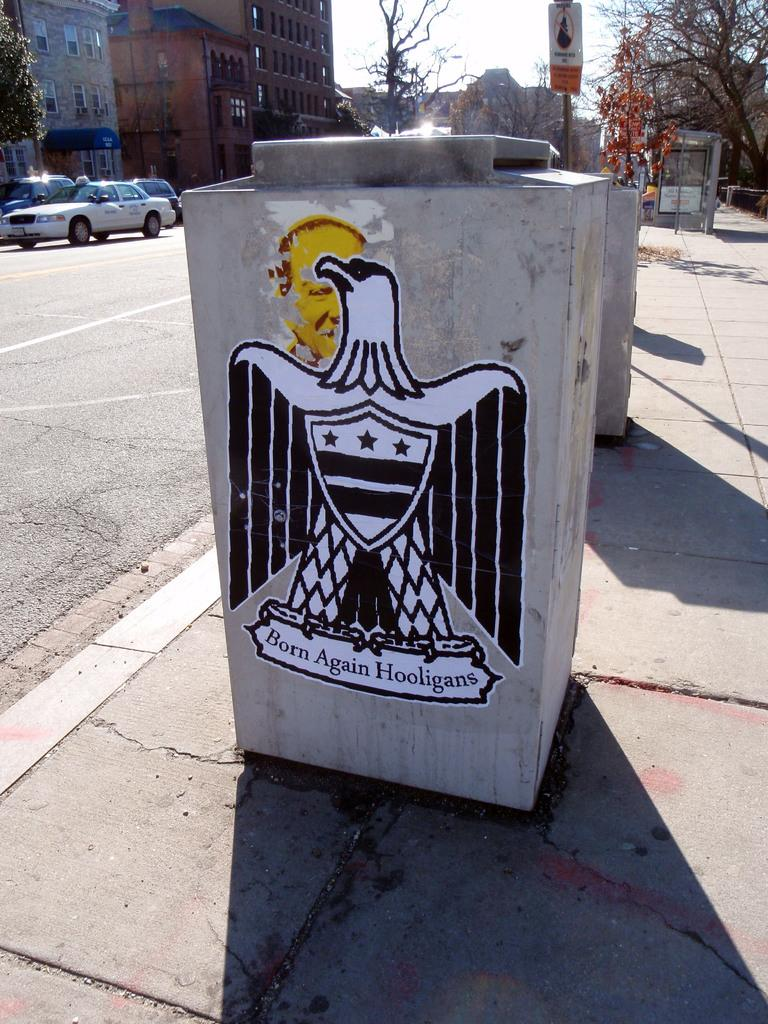<image>
Give a short and clear explanation of the subsequent image. A concrete trash can has a drawing of an eagle on it and the word born written beneath. 